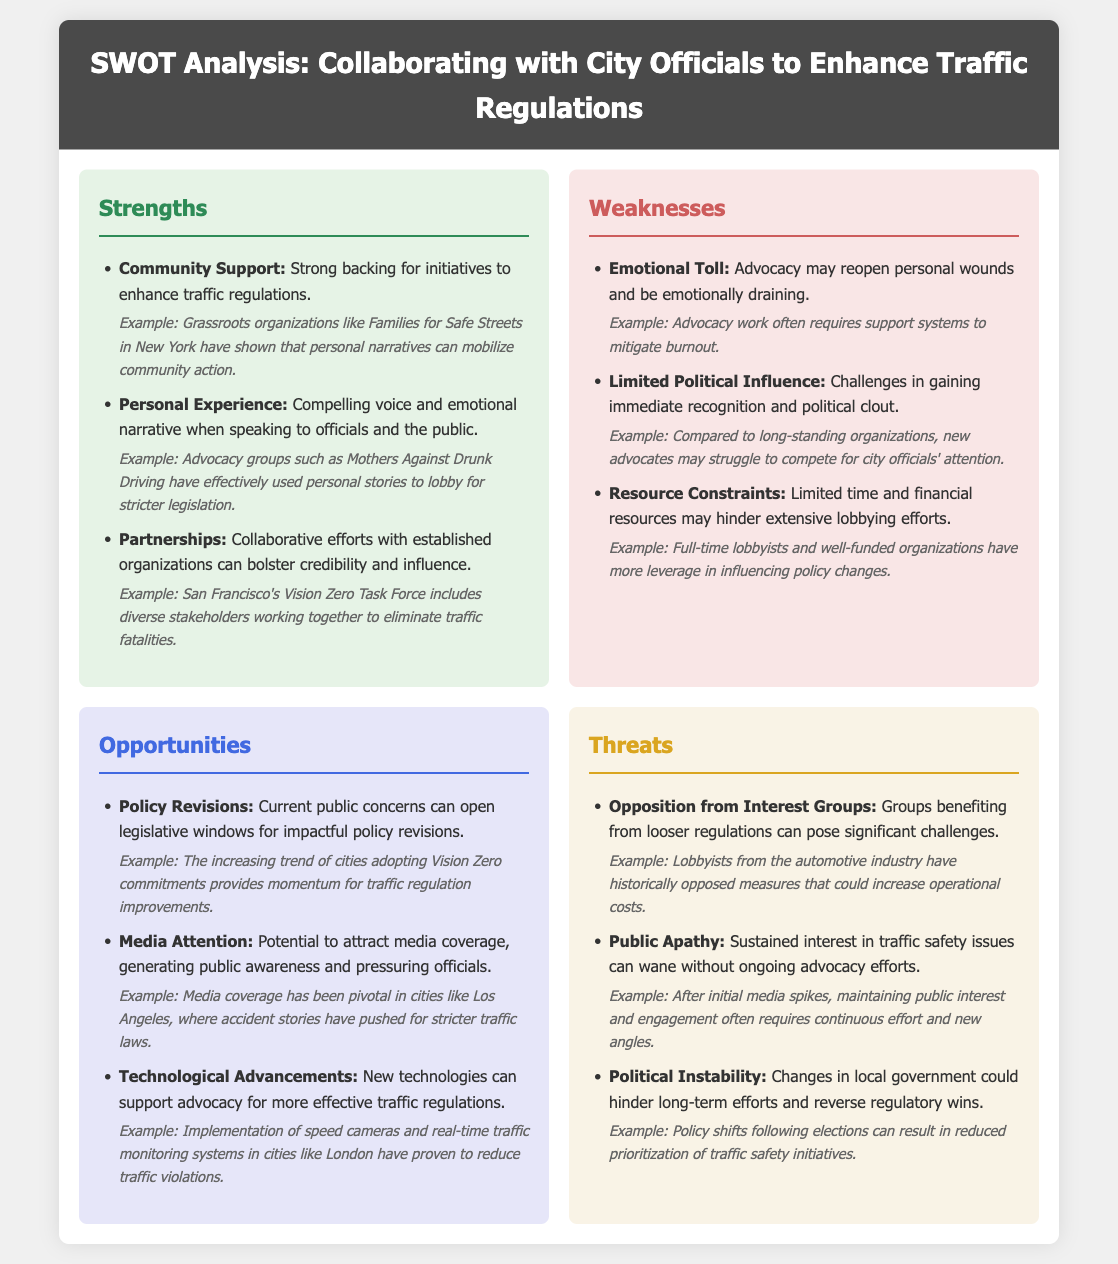What is one of the strengths listed in the document? The document lists community support as one of the strengths of collaborating with city officials.
Answer: Community Support What emotional challenge is mentioned as a weakness? The document mentions the emotional toll advocacy may take, which can be emotionally draining.
Answer: Emotional Toll What opportunity involves attracting media coverage? The document mentions that media attention can generate public awareness and pressure officials.
Answer: Media Attention Which group is cited as a potential opposition in the threats section? The document references interest groups benefiting from looser regulations as potential opposition.
Answer: Interest Groups What example is given for a strength related to partnerships? The document provides an example of San Francisco's Vision Zero Task Force as showcasing effective partnerships.
Answer: Vision Zero Task Force What is a potential threat related to public interest? The document states that public apathy can lead to a decrease in sustained interest in traffic safety issues.
Answer: Public Apathy What technological advancement is mentioned as an opportunity? The document references new technologies supporting advocacy for effective traffic regulations.
Answer: New Technologies How can current public concerns influence policy, according to the document? The document suggests that current public concerns can open legislative windows for impactful policy revisions.
Answer: Policy Revisions What example in the threats section refers to political changes? The document cites policy shifts following elections as a threat to long-term efforts.
Answer: Policy Shifts Following Elections 